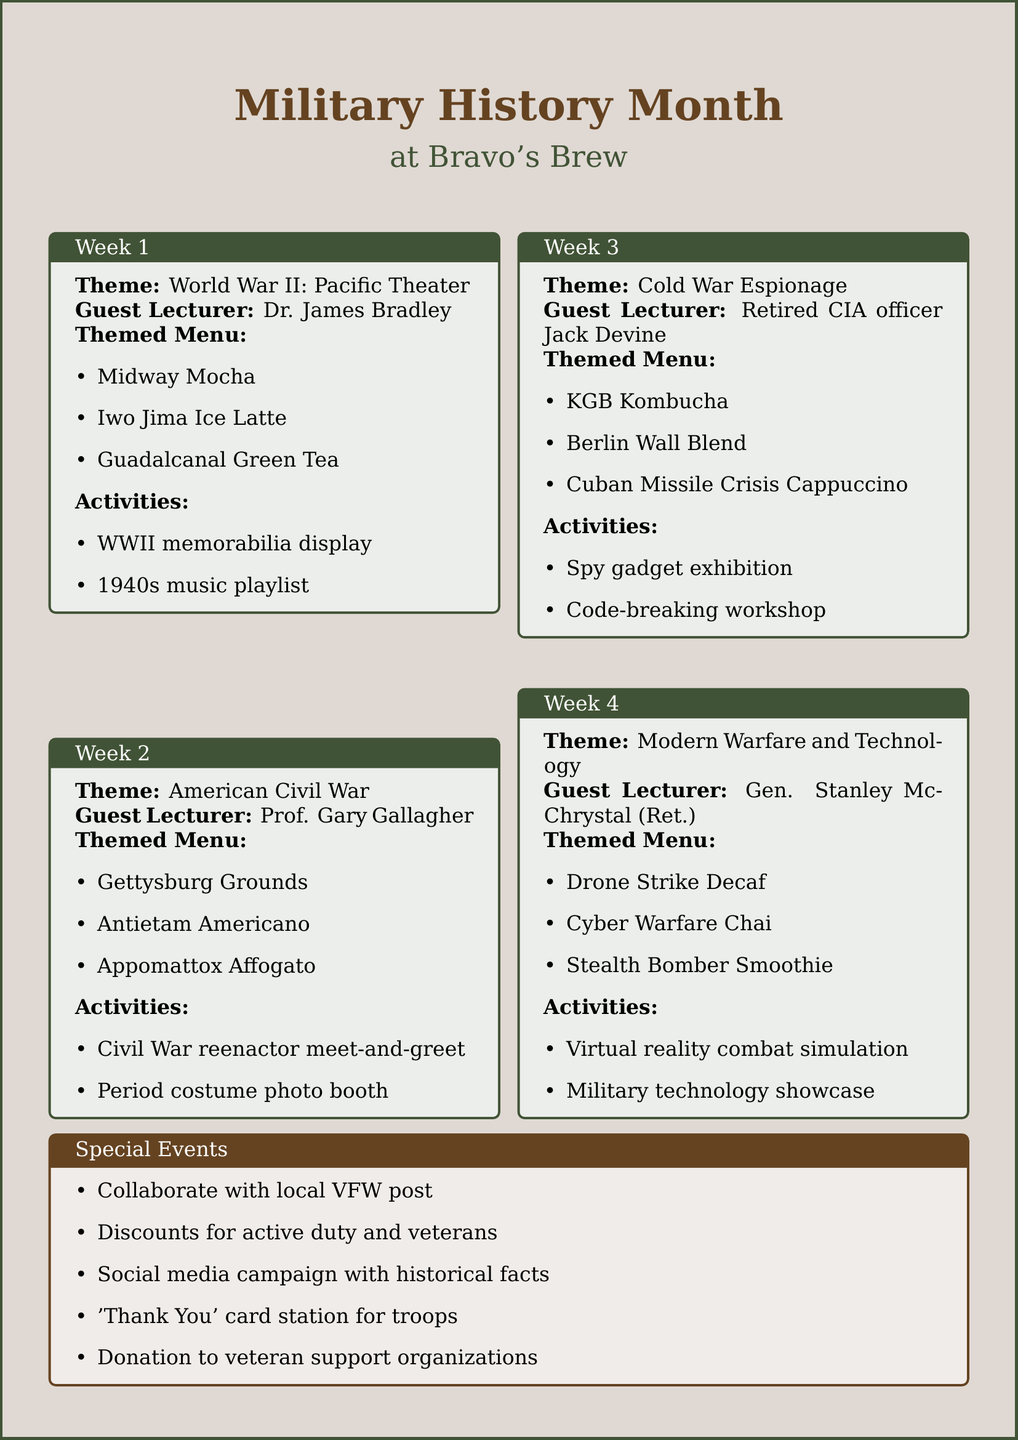What is the theme of Week 1? The theme of Week 1 is specifically mentioned in the document under Week 1 details.
Answer: World War II: Pacific Theater Who is the guest lecturer for Week 2? The guest lecturer is provided clearly in the Week 2 section of the document.
Answer: Prof. Gary Gallagher What are the themed menu items for Week 3? The themed menu items are listed under the Week 3 activities, detailing specific drinks.
Answer: KGB Kombucha, Berlin Wall Blend, Cuban Missile Crisis Cappuccino How many weeks does the event series last? The event series duration is stated explicitly in the document.
Answer: 4 weeks What activities are planned for Week 4? The activities for Week 4 are enumerated in the Week 4 section and require pulling multiple items together.
Answer: Virtual reality combat simulation, Military technology showcase What marketing idea involves local veterans? This marketing idea is explicitly included in the marketing section, focusing on veterans.
Answer: Collaborate with local VFW post for promotion Which themed menu item is associated with the American Civil War? This themed menu item is specifically mentioned in the Week 2 section about that period.
Answer: Gettysburg Grounds What type of community outreach is mentioned in the document? The document lists specific outreach actions planned as part of the event activities.
Answer: Donate a portion of proceeds to veteran support organizations What is the purpose of the 'Thank You' card station? The purpose is explained briefly in relation to community outreach efforts within the document.
Answer: To write notes to troops 